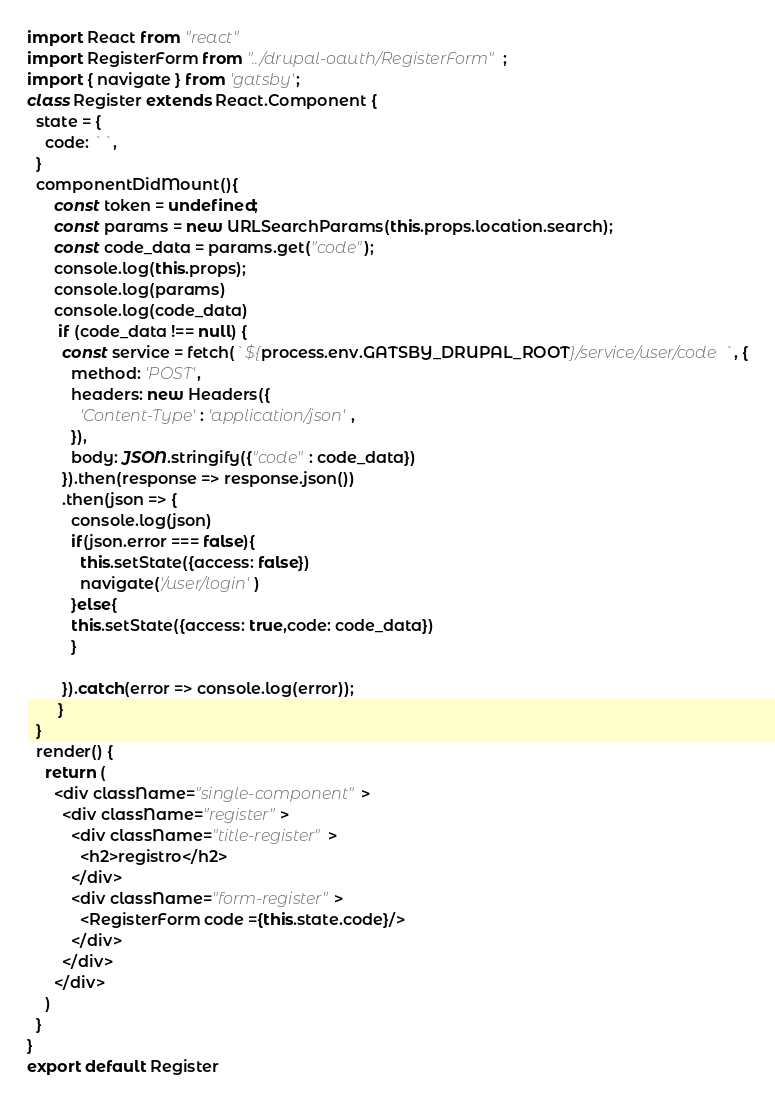Convert code to text. <code><loc_0><loc_0><loc_500><loc_500><_JavaScript_>import React from "react"
import RegisterForm from "../drupal-oauth/RegisterForm";
import { navigate } from 'gatsby';
class Register extends React.Component {
  state = {
    code: ``,
  }
  componentDidMount(){
      const token = undefined;
      const params = new URLSearchParams(this.props.location.search);
      const code_data = params.get("code");
      console.log(this.props);
      console.log(params)
      console.log(code_data)
       if (code_data !== null) {
        const service = fetch(`${process.env.GATSBY_DRUPAL_ROOT}/service/user/code`, {
          method: 'POST',
          headers: new Headers({
            'Content-Type': 'application/json',
          }),
          body: JSON.stringify({"code" : code_data})
        }).then(response => response.json())
        .then(json => {
          console.log(json)
          if(json.error === false){
            this.setState({access: false})
            navigate('/user/login')
          }else{
          this.setState({access: true,code: code_data})
          }

        }).catch(error => console.log(error));
       }
  }
  render() {
    return (
      <div className="single-component">
        <div className="register">
          <div className="title-register">
            <h2>registro</h2>
          </div>
          <div className="form-register">
            <RegisterForm code ={this.state.code}/>
          </div>
        </div>
      </div>
    )
  }
}
export default Register
</code> 